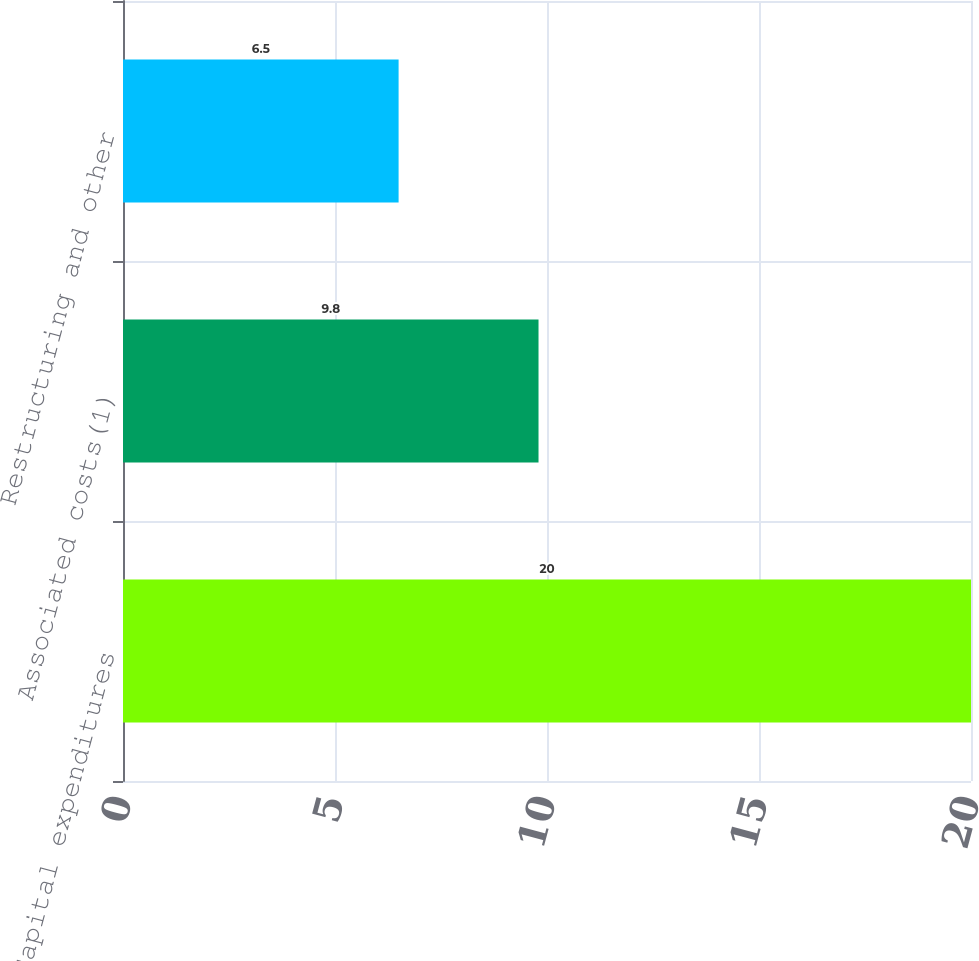Convert chart. <chart><loc_0><loc_0><loc_500><loc_500><bar_chart><fcel>Capital expenditures<fcel>Associated costs(1)<fcel>Restructuring and other<nl><fcel>20<fcel>9.8<fcel>6.5<nl></chart> 